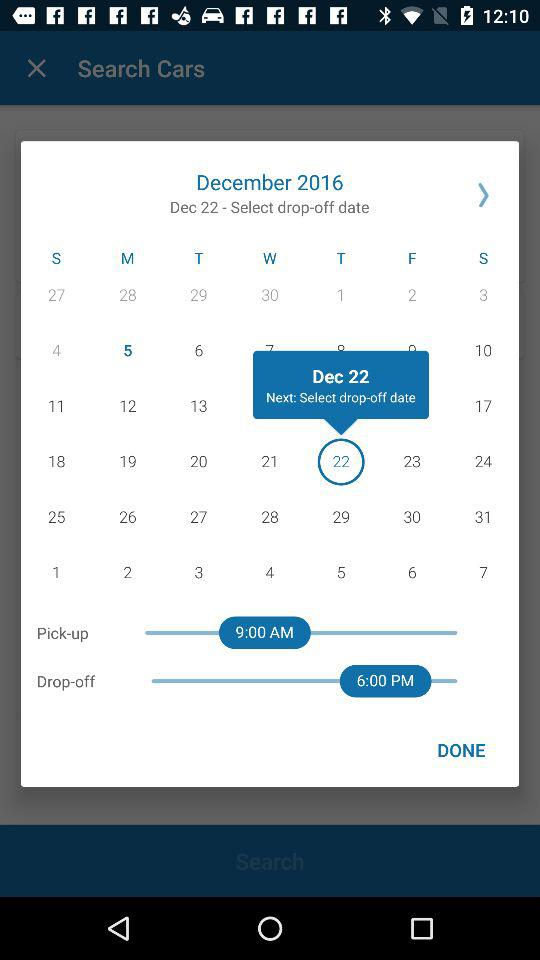What is the selected pick-up date? The selected date is Thursday, December 22, 2016. 